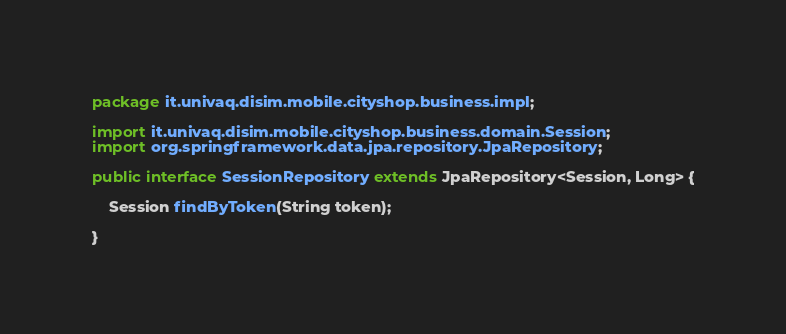Convert code to text. <code><loc_0><loc_0><loc_500><loc_500><_Java_>package it.univaq.disim.mobile.cityshop.business.impl;

import it.univaq.disim.mobile.cityshop.business.domain.Session;
import org.springframework.data.jpa.repository.JpaRepository;

public interface SessionRepository extends JpaRepository<Session, Long> {

    Session findByToken(String token);

}
</code> 